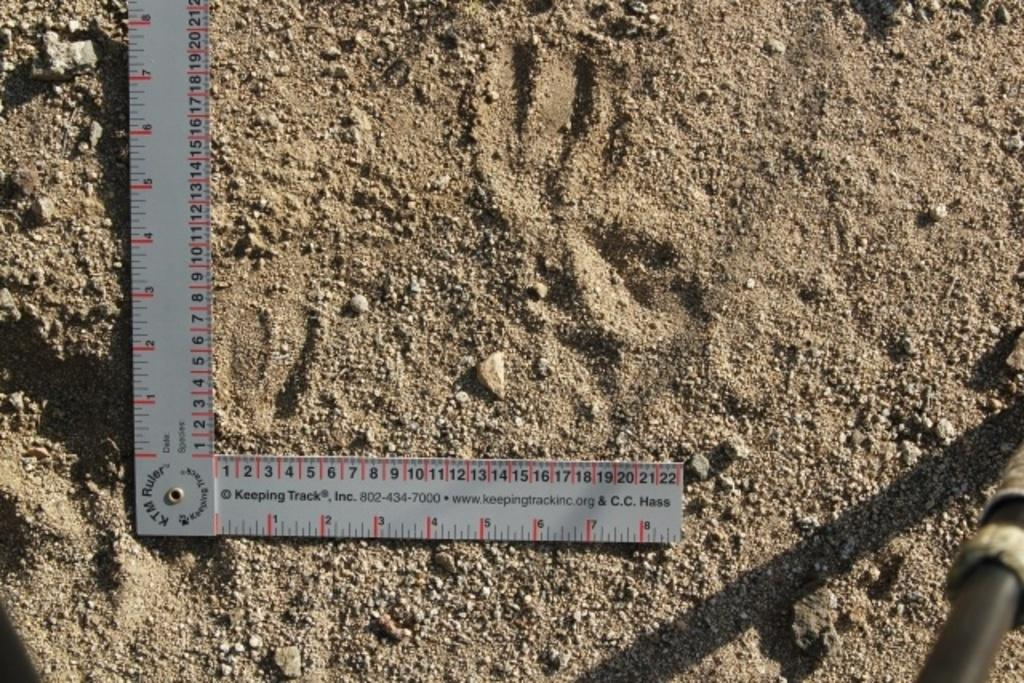<image>
Provide a brief description of the given image. A KTM Ruler is a set square with ruler markings. 